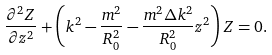Convert formula to latex. <formula><loc_0><loc_0><loc_500><loc_500>\frac { \partial ^ { 2 } Z } { \partial z ^ { 2 } } + \left ( k ^ { 2 } - \frac { m ^ { 2 } } { R _ { 0 } ^ { 2 } } - \frac { m ^ { 2 } \Delta k ^ { 2 } } { R _ { 0 } ^ { 2 } } z ^ { 2 } \right ) Z = 0 .</formula> 